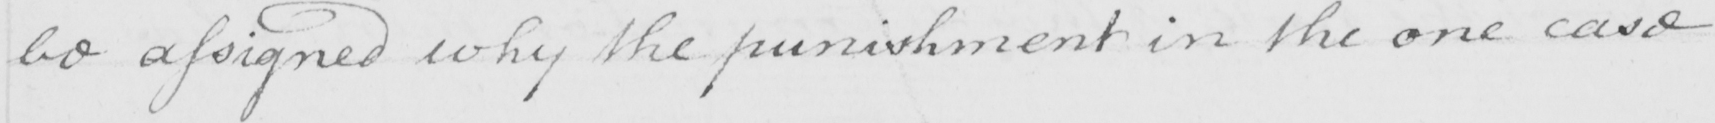What is written in this line of handwriting? be assigned why the punishment in the one case 